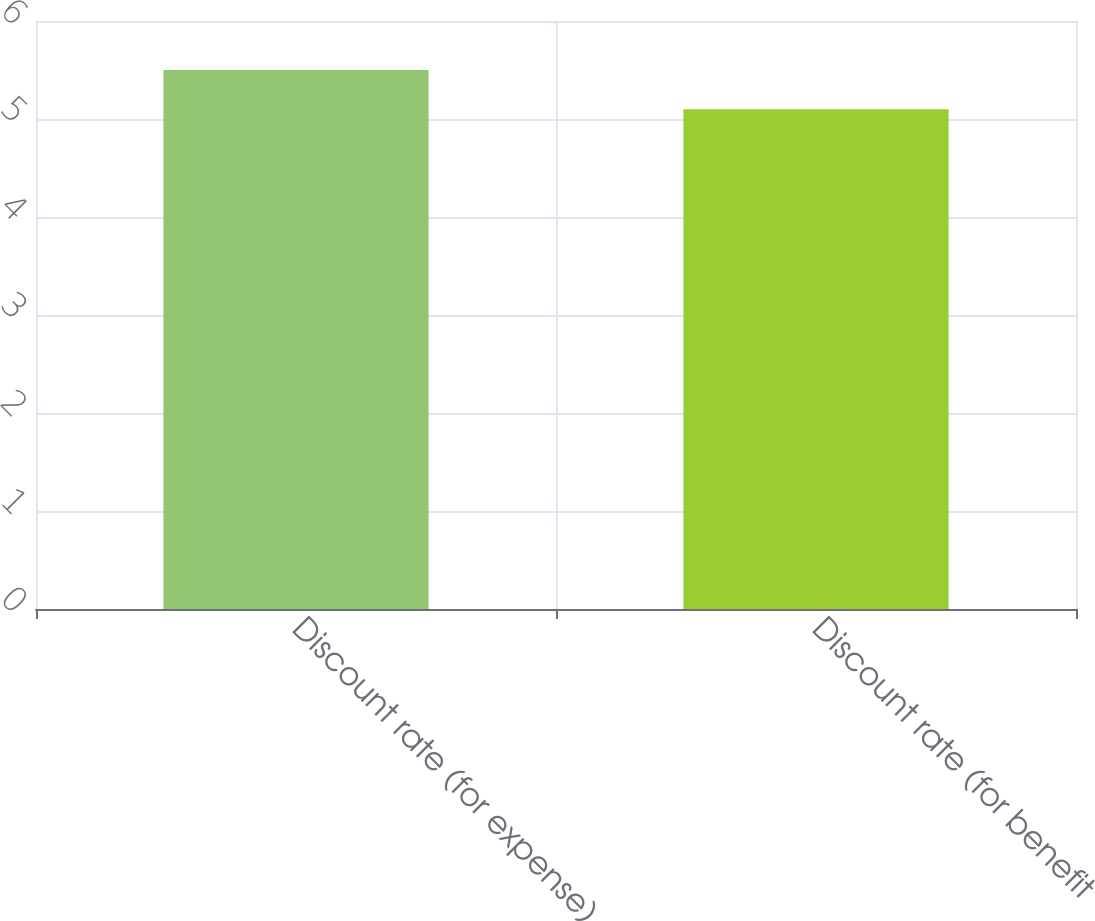Convert chart. <chart><loc_0><loc_0><loc_500><loc_500><bar_chart><fcel>Discount rate (for expense)<fcel>Discount rate (for benefit<nl><fcel>5.5<fcel>5.1<nl></chart> 